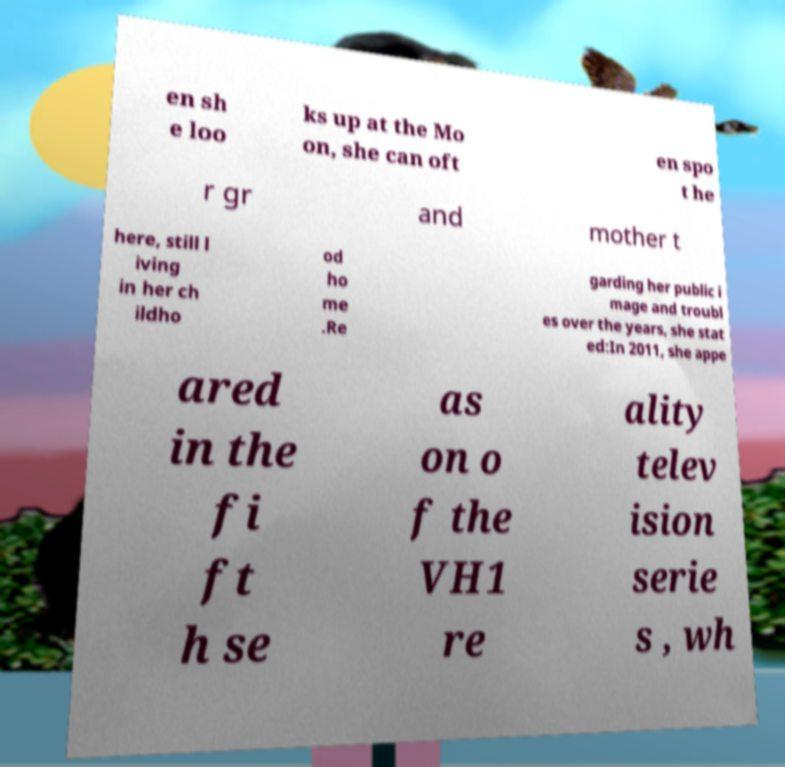There's text embedded in this image that I need extracted. Can you transcribe it verbatim? en sh e loo ks up at the Mo on, she can oft en spo t he r gr and mother t here, still l iving in her ch ildho od ho me .Re garding her public i mage and troubl es over the years, she stat ed:In 2011, she appe ared in the fi ft h se as on o f the VH1 re ality telev ision serie s , wh 